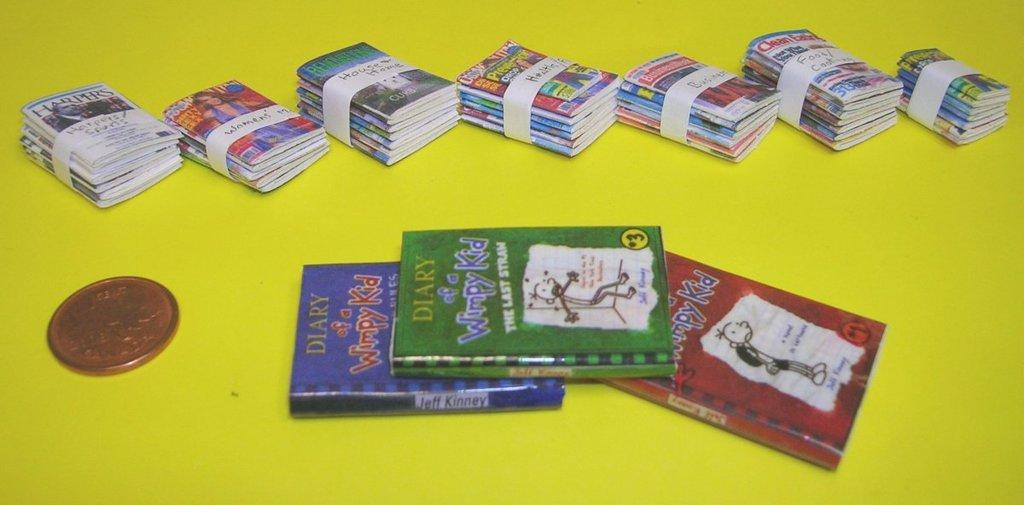Provide a one-sentence caption for the provided image. Seven stacks of paperback books behind four Diary of a Wimpy Kid books. 